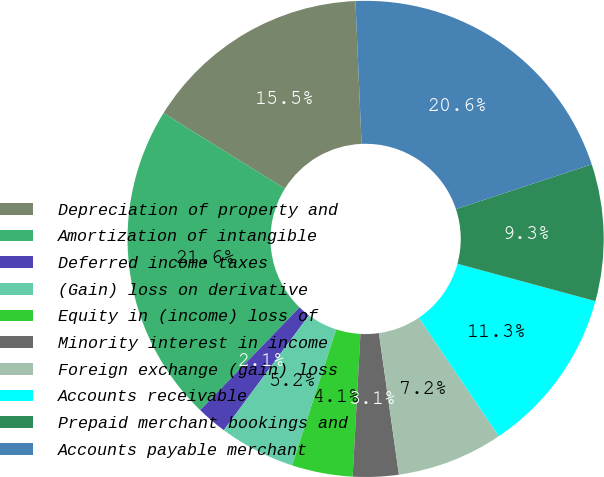Convert chart. <chart><loc_0><loc_0><loc_500><loc_500><pie_chart><fcel>Depreciation of property and<fcel>Amortization of intangible<fcel>Deferred income taxes<fcel>(Gain) loss on derivative<fcel>Equity in (income) loss of<fcel>Minority interest in income<fcel>Foreign exchange (gain) loss<fcel>Accounts receivable<fcel>Prepaid merchant bookings and<fcel>Accounts payable merchant<nl><fcel>15.46%<fcel>21.64%<fcel>2.07%<fcel>5.16%<fcel>4.13%<fcel>3.1%<fcel>7.22%<fcel>11.34%<fcel>9.28%<fcel>20.61%<nl></chart> 